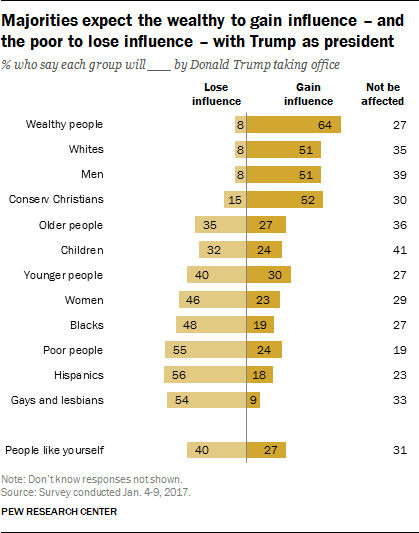Draw attention to some important aspects in this diagram. The total percentage of men and women who lose influence is greater than 50. The gain influence value of wealthy people is 0.64. 